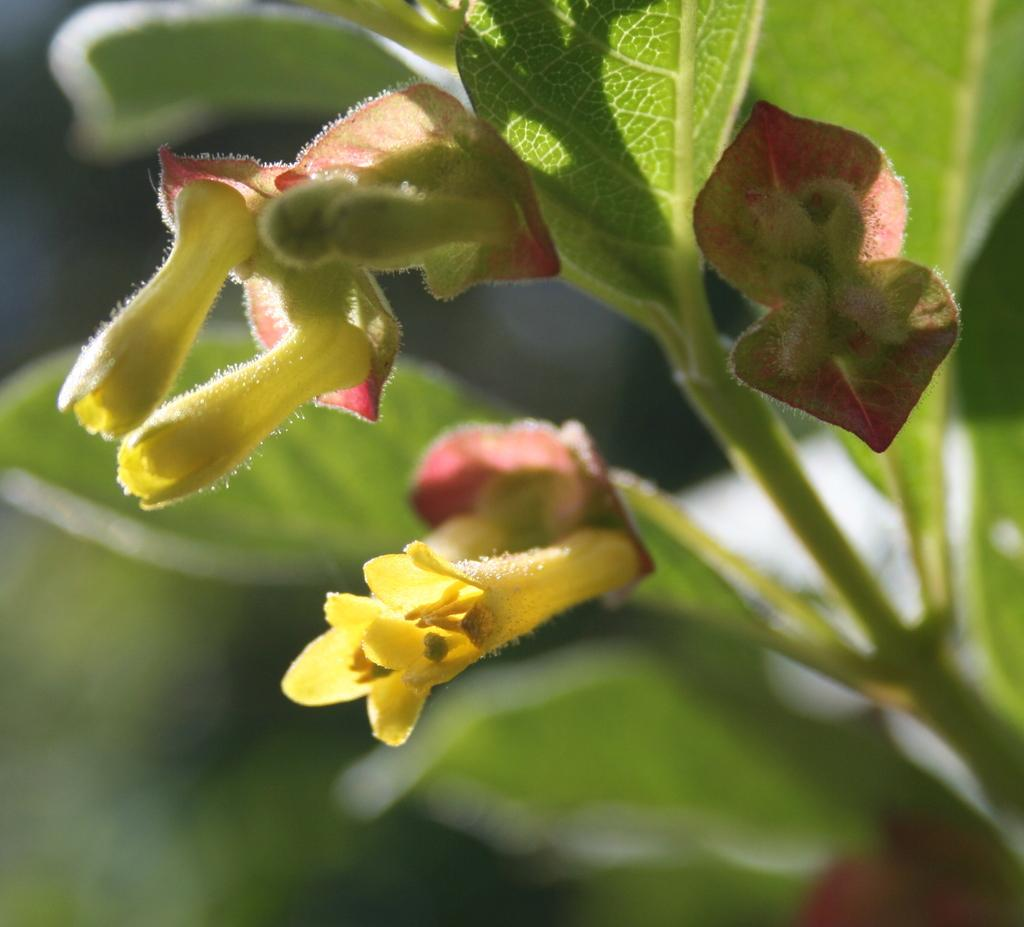What types of living organisms can be seen in the image? Plants and flowers are visible in the image. What stage of growth can be observed in the plants? There are buds in the image, indicating that some of the plants are in the early stages of growth. How would you describe the background of the image? The background of the image is blurred. What type of jam is being sold at the shop in the image? There is no shop or jam present in the image; it features plants and flowers with a blurred background. What gardening tool is being used to dig up the soil in the image? There is no gardening tool or soil digging activity depicted in the image; it only shows plants, flowers, and buds. 